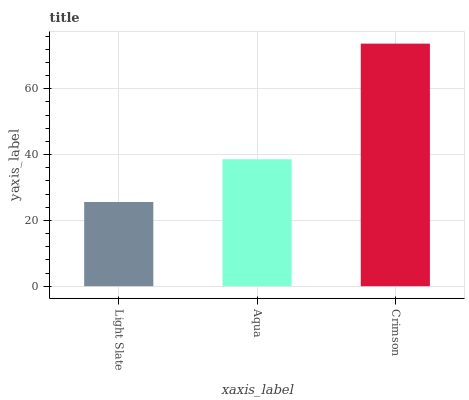Is Aqua the minimum?
Answer yes or no. No. Is Aqua the maximum?
Answer yes or no. No. Is Aqua greater than Light Slate?
Answer yes or no. Yes. Is Light Slate less than Aqua?
Answer yes or no. Yes. Is Light Slate greater than Aqua?
Answer yes or no. No. Is Aqua less than Light Slate?
Answer yes or no. No. Is Aqua the high median?
Answer yes or no. Yes. Is Aqua the low median?
Answer yes or no. Yes. Is Crimson the high median?
Answer yes or no. No. Is Light Slate the low median?
Answer yes or no. No. 